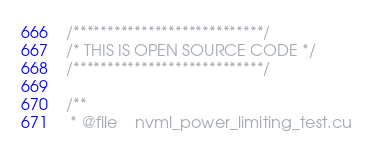<code> <loc_0><loc_0><loc_500><loc_500><_Cuda_>/****************************/
/* THIS IS OPEN SOURCE CODE */
/****************************/

/**
 * @file    nvml_power_limiting_test.cu</code> 